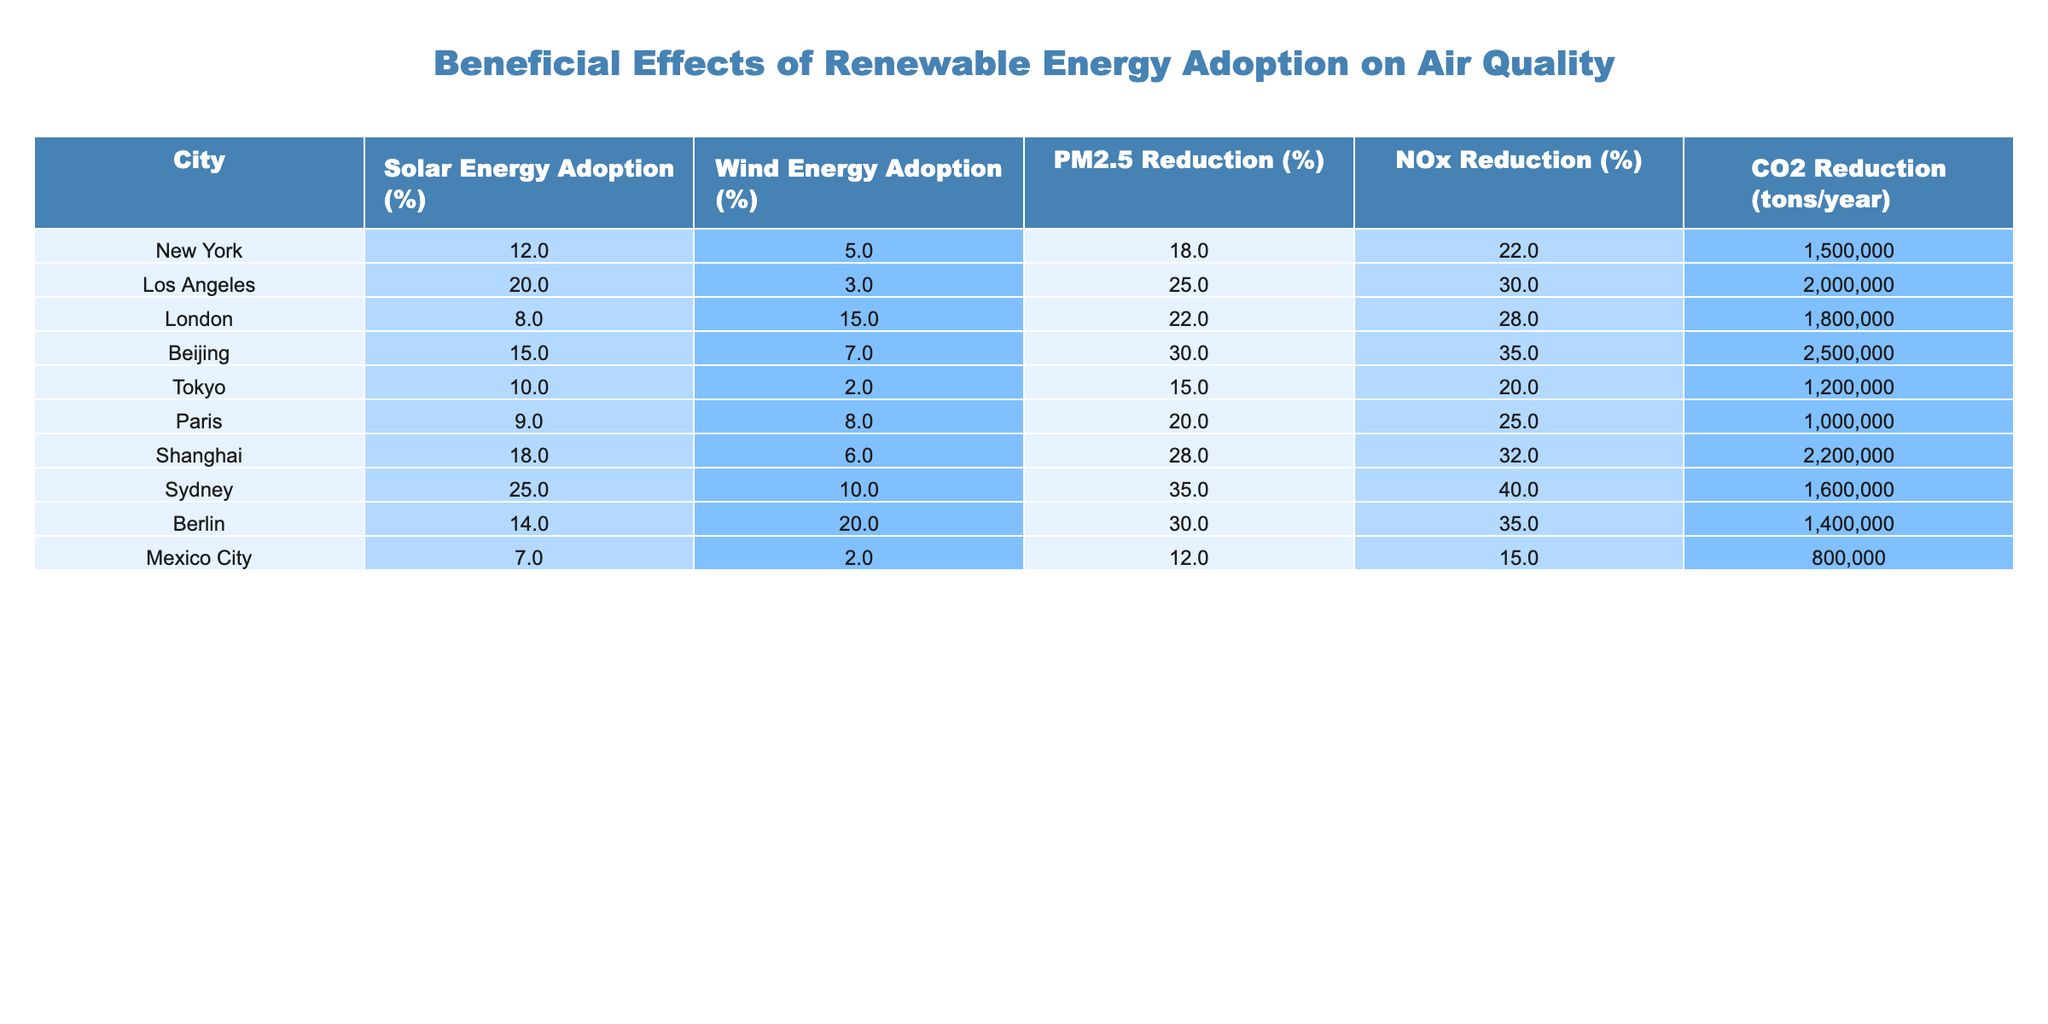What is the PM2.5 reduction percentage for Sydney? Referring to the table, the PM2.5 reduction percentage for Sydney is listed directly under that column. The value is 35%.
Answer: 35% Which city has the highest wind energy adoption percentage? Looking at the wind energy adoption column, Berlin shows the highest percentage at 20%.
Answer: Berlin What is the total CO2 reduction (in tons/year) from all the cities listed? To find the total CO2 reduction, we sum the values from the CO2 reduction column: (1500000 + 2000000 + 1800000 + 2500000 + 1200000 + 1000000 + 2200000 + 1600000 + 1400000 + 800000) = 14900000 tons/year.
Answer: 14900000 tons/year Is the NOx reduction percentage for Paris higher than that of Tokyo? In the NOx reduction column, Paris has a value of 25%, while Tokyo has a value of 20%, making Paris's value higher.
Answer: Yes What is the average solar energy adoption percentage among the cities listed? The solar energy adoption percentages are: 12, 20, 8, 15, 10, 9, 18, 25, 14, and 7. The total sum is 12 + 20 + 8 + 15 + 10 + 9 + 18 + 25 + 14 + 7 = 138, and there are 10 cities, so the average is 138/10 = 13.8%.
Answer: 13.8% Which city shows both the highest PM2.5 and CO2 reduction? In the given table, Sydney shows the highest PM2.5 reduction at 35% and CO2 reduction at 1600000 tons/year while comparing with other cities.
Answer: Sydney What is the difference in PM2.5 reduction between Beijing and Los Angeles? The PM2.5 reduction for Beijing is 30%, and for Los Angeles, it is 25%. The difference is 30% - 25% = 5%.
Answer: 5% Are there cities where solar energy adoption is above 20%? Looking through the solar energy adoption percentages, only Sydney has a value above 20% at 25%.
Answer: Yes What is the total PM2.5 reduction percentage for cities that have a CO2 reduction of more than 2 million tons/year? The cities with CO2 reduction over 2 million tons/year are Los Angeles (25% PM2.5), Beijing (30% PM2.5), and Shanghai (28% PM2.5). Total PM2.5 reduction is 25% + 30% + 28% = 83%.
Answer: 83% Is there a linear relationship between solar energy adoption and PM2.5 reduction based on this table? To assess this, one would evaluate the values across both columns to see if higher solar adoption corresponds directly to higher PM2.5 reductions. The values do not show a clear linearity upon inspection.
Answer: No 